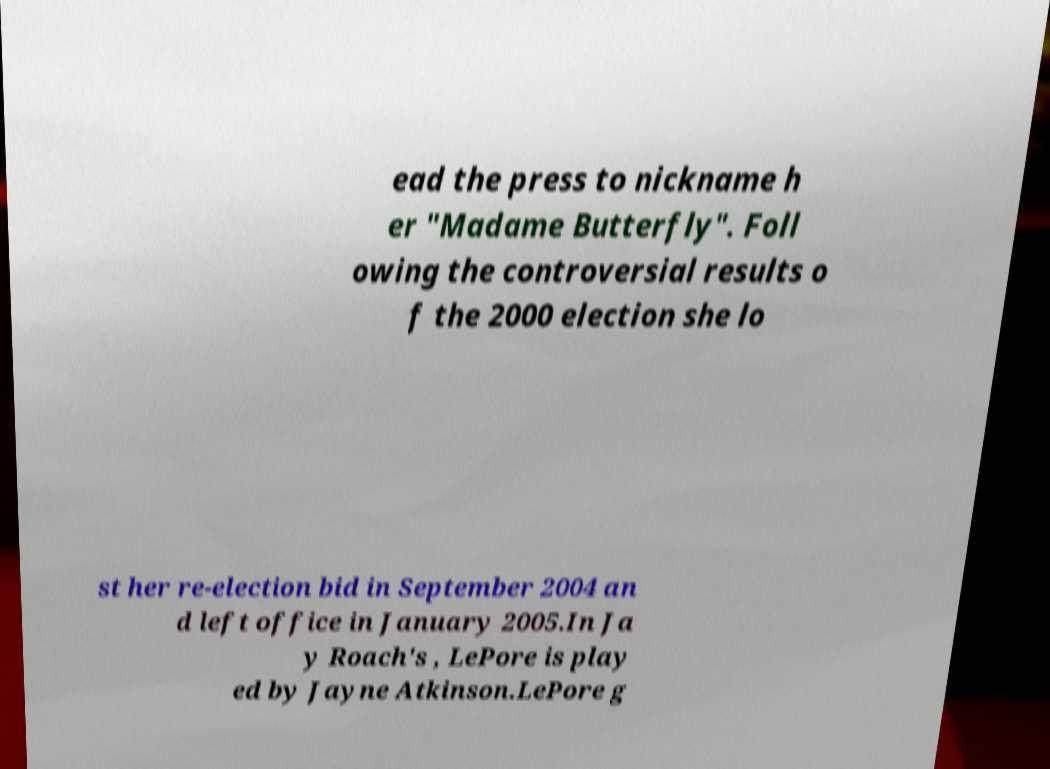Please read and relay the text visible in this image. What does it say? ead the press to nickname h er "Madame Butterfly". Foll owing the controversial results o f the 2000 election she lo st her re-election bid in September 2004 an d left office in January 2005.In Ja y Roach's , LePore is play ed by Jayne Atkinson.LePore g 